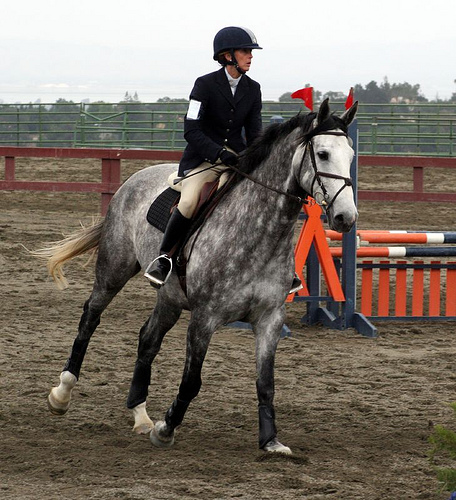<image>
Is the fence on the horse? No. The fence is not positioned on the horse. They may be near each other, but the fence is not supported by or resting on top of the horse. 